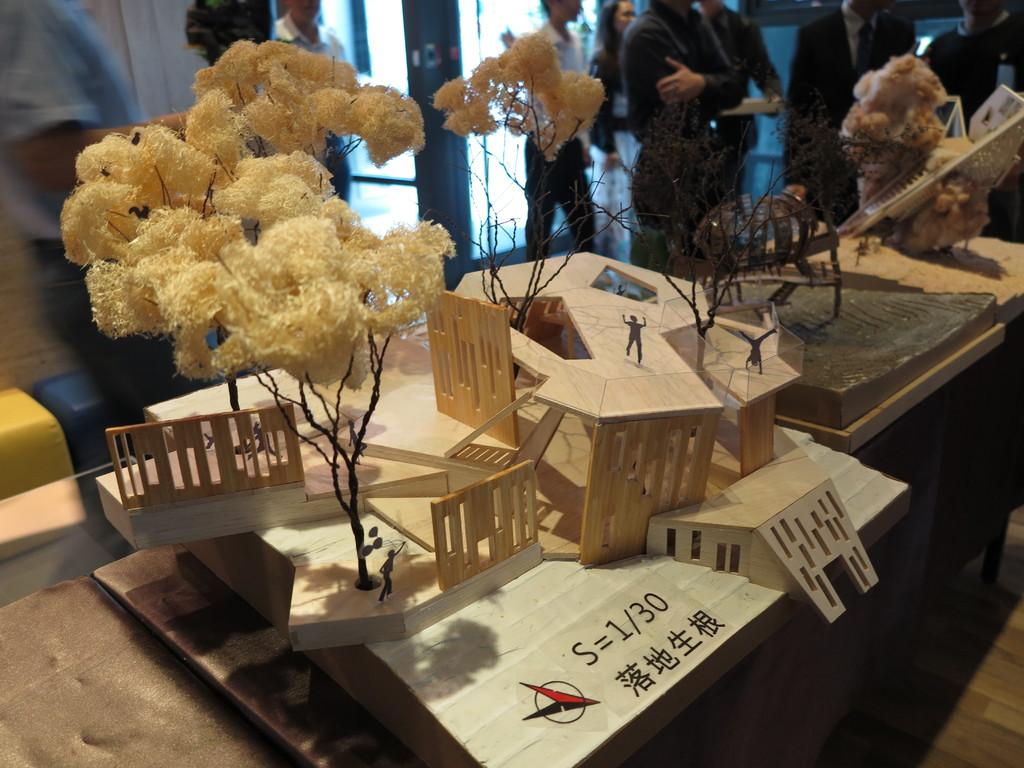What is the main object in the image? There is a table in the image. What is on the table? Fine arts, including a tree and people on the roof of a building, are present on the table. Are there any people visible in the image? Yes, there are people standing behind the table. What else can be seen in the image? There is a door visible in the image. What type of locket is hanging from the tree in the image? There is no locket present in the image; the fine arts on the table include a tree and people on the roof of a building, but no locket is visible. 